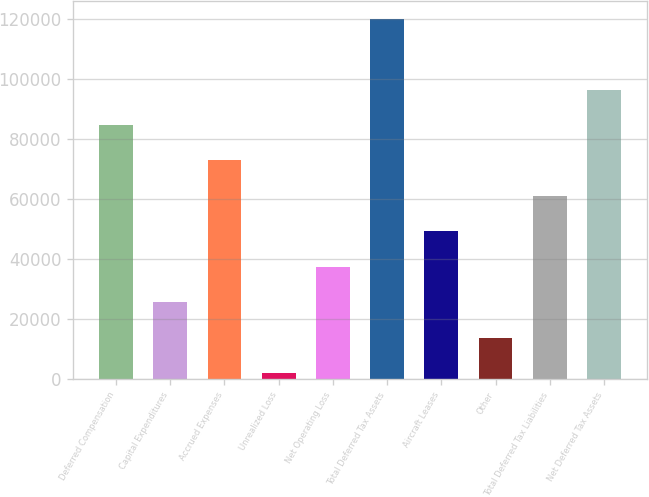Convert chart. <chart><loc_0><loc_0><loc_500><loc_500><bar_chart><fcel>Deferred Compensation<fcel>Capital Expenditures<fcel>Accrued Expenses<fcel>Unrealized Loss<fcel>Net Operating Loss<fcel>Total Deferred Tax Assets<fcel>Aircraft Leases<fcel>Other<fcel>Total Deferred Tax Liabilities<fcel>Net Deferred Tax Assets<nl><fcel>84721<fcel>25586<fcel>72894<fcel>1932<fcel>37413<fcel>120202<fcel>49240<fcel>13759<fcel>61067<fcel>96548<nl></chart> 